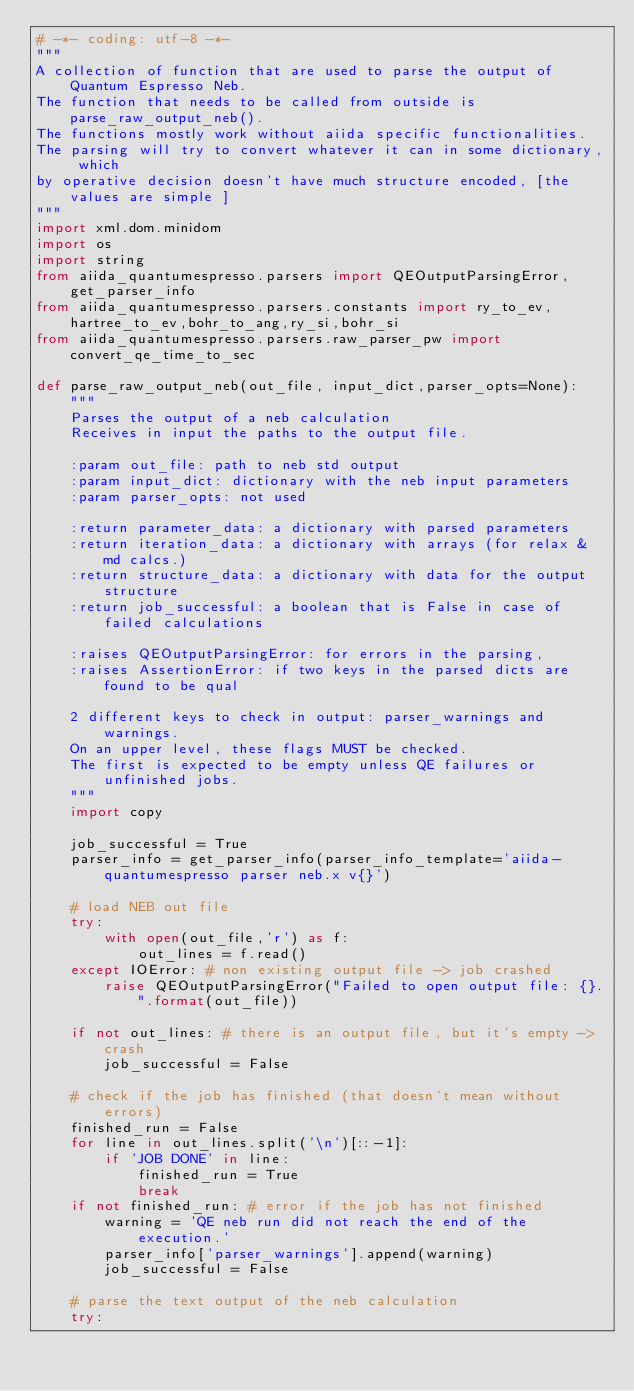Convert code to text. <code><loc_0><loc_0><loc_500><loc_500><_Python_># -*- coding: utf-8 -*-
"""
A collection of function that are used to parse the output of Quantum Espresso Neb.
The function that needs to be called from outside is parse_raw_output_neb().
The functions mostly work without aiida specific functionalities.
The parsing will try to convert whatever it can in some dictionary, which
by operative decision doesn't have much structure encoded, [the values are simple ] 
"""
import xml.dom.minidom
import os
import string
from aiida_quantumespresso.parsers import QEOutputParsingError, get_parser_info
from aiida_quantumespresso.parsers.constants import ry_to_ev,hartree_to_ev,bohr_to_ang,ry_si,bohr_si
from aiida_quantumespresso.parsers.raw_parser_pw import convert_qe_time_to_sec

def parse_raw_output_neb(out_file, input_dict,parser_opts=None):
    """
    Parses the output of a neb calculation
    Receives in input the paths to the output file.
    
    :param out_file: path to neb std output
    :param input_dict: dictionary with the neb input parameters
    :param parser_opts: not used
    
    :return parameter_data: a dictionary with parsed parameters
    :return iteration_data: a dictionary with arrays (for relax & md calcs.)
    :return structure_data: a dictionary with data for the output structure
    :return job_successful: a boolean that is False in case of failed calculations
            
    :raises QEOutputParsingError: for errors in the parsing,
    :raises AssertionError: if two keys in the parsed dicts are found to be qual

    2 different keys to check in output: parser_warnings and warnings.
    On an upper level, these flags MUST be checked.
    The first is expected to be empty unless QE failures or unfinished jobs.
    """
    import copy

    job_successful = True
    parser_info = get_parser_info(parser_info_template='aiida-quantumespresso parser neb.x v{}')
    
    # load NEB out file
    try:
        with open(out_file,'r') as f:
            out_lines = f.read()
    except IOError: # non existing output file -> job crashed
        raise QEOutputParsingError("Failed to open output file: {}.".format(out_file))

    if not out_lines: # there is an output file, but it's empty -> crash
        job_successful = False

    # check if the job has finished (that doesn't mean without errors)
    finished_run = False
    for line in out_lines.split('\n')[::-1]:
        if 'JOB DONE' in line:
            finished_run = True
            break
    if not finished_run: # error if the job has not finished
        warning = 'QE neb run did not reach the end of the execution.'
        parser_info['parser_warnings'].append(warning)        
        job_successful = False

    # parse the text output of the neb calculation
    try: </code> 